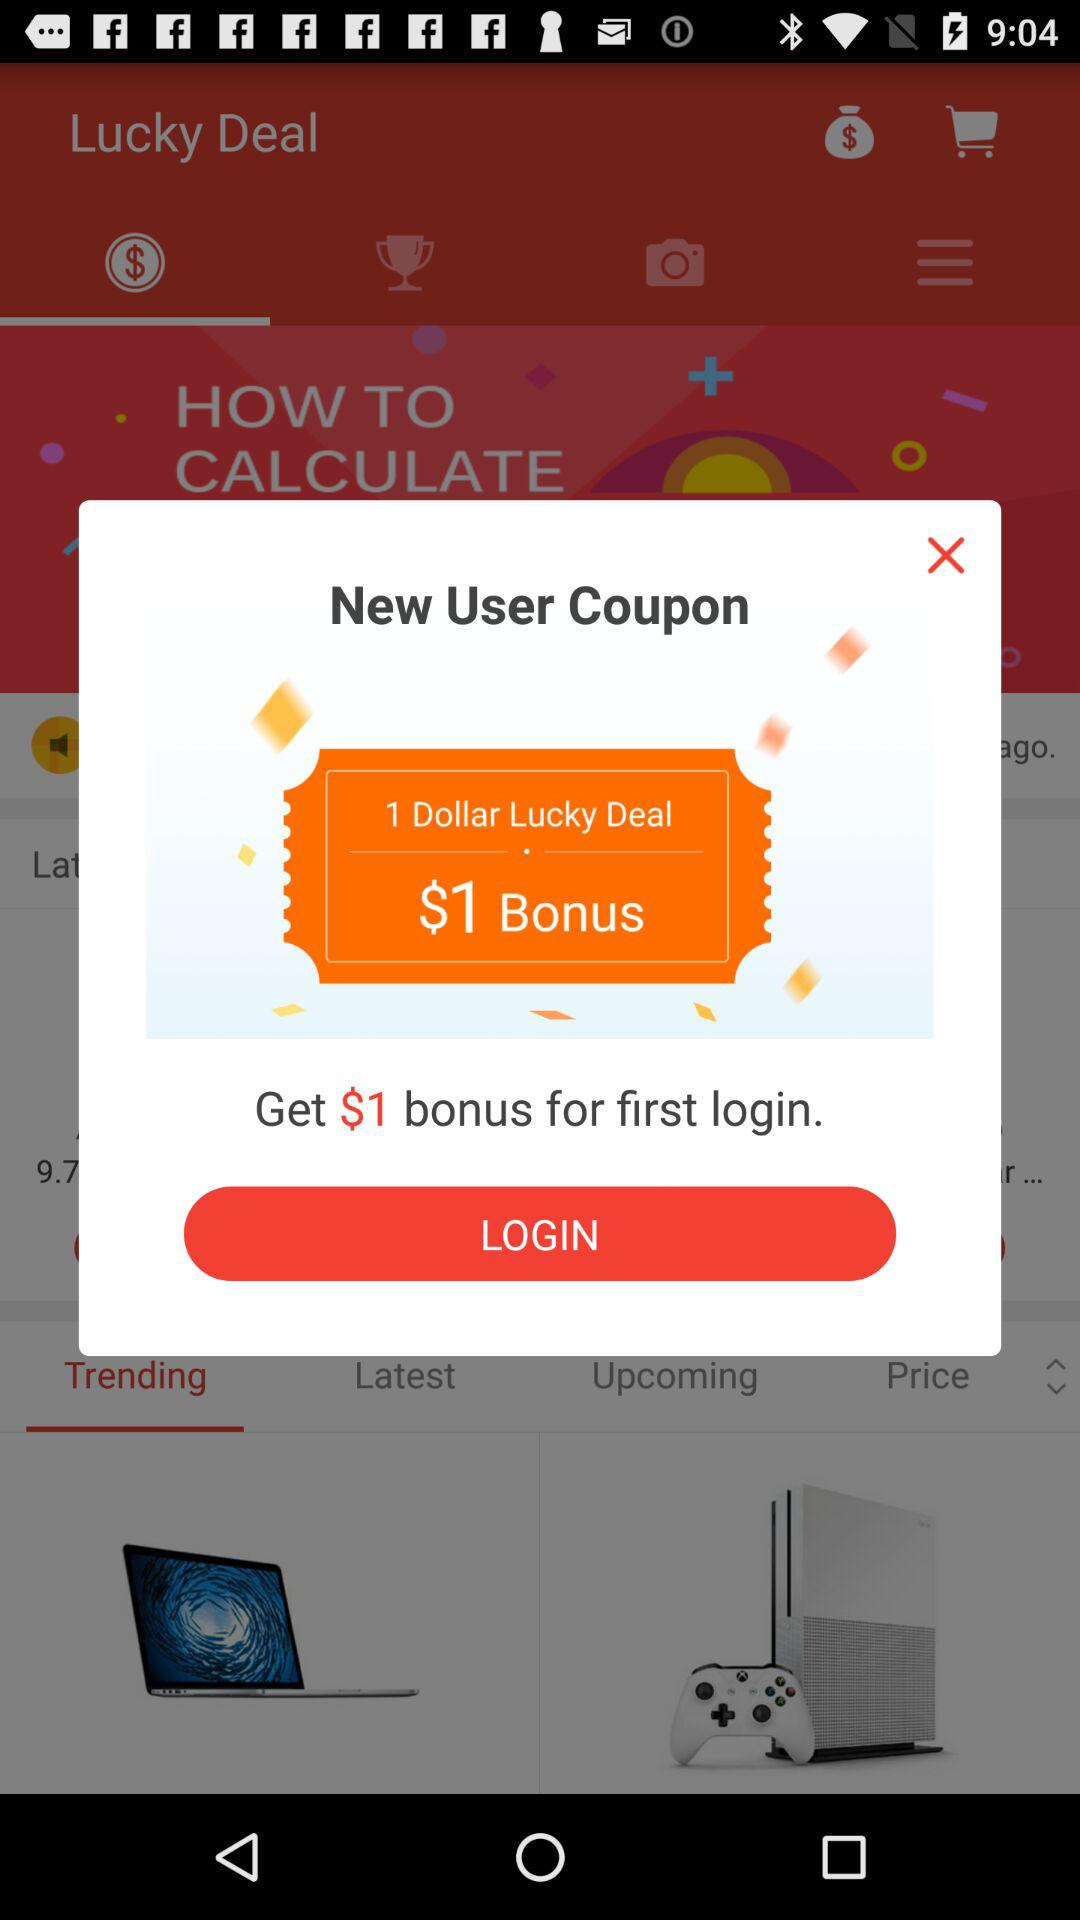How many dollars are offered as a bonus to first-time logins?
Answer the question using a single word or phrase. $1 